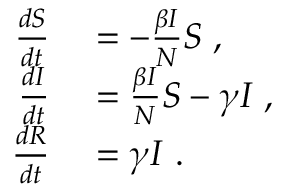<formula> <loc_0><loc_0><loc_500><loc_500>\begin{array} { r l } { \frac { d S } { d t } } & = - \frac { \beta I } { N } S \, , } \\ { \frac { d I } { d t } } & = \frac { \beta I } { N } S - \gamma I \, , } \\ { \frac { d R } { d t } } & = \gamma I \, . } \end{array}</formula> 